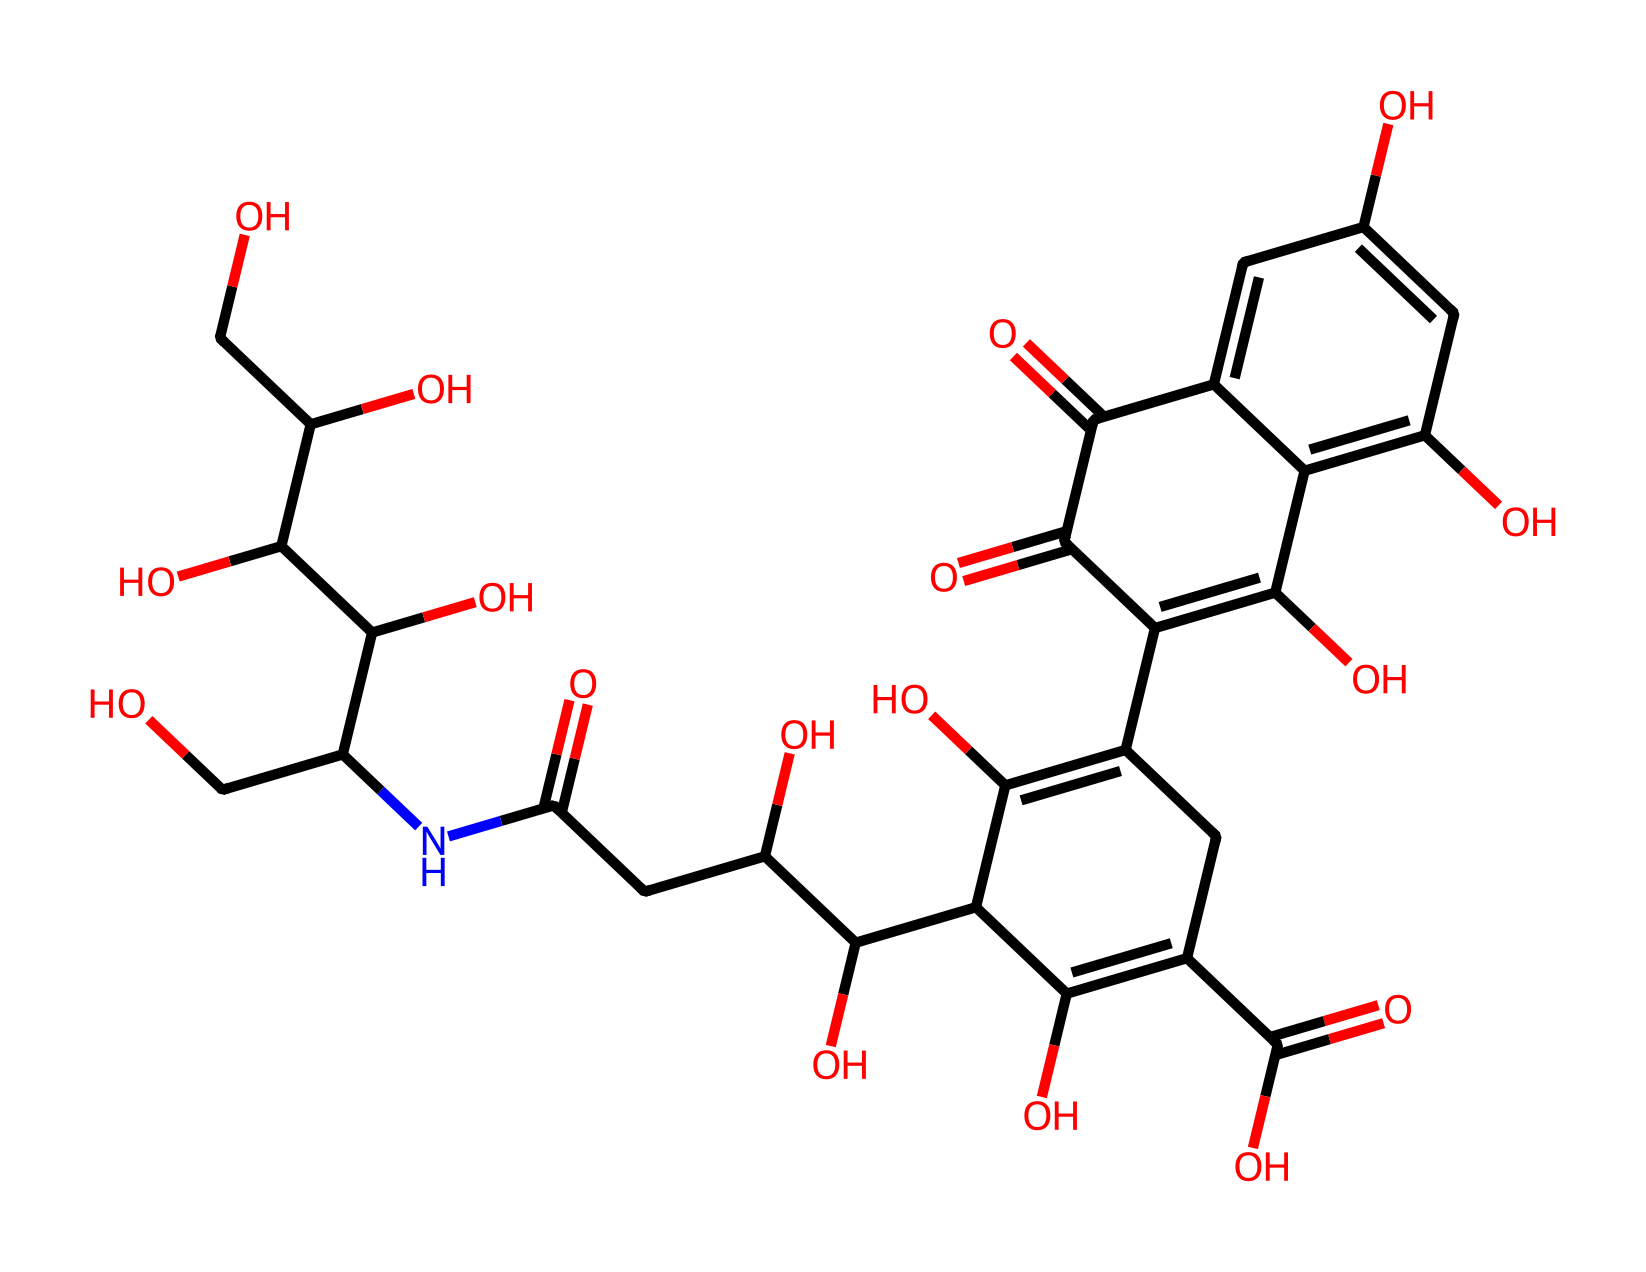What is the molecular formula of betanin? To determine the molecular formula, we count all the different atoms present in the SMILES representation. Looking through the structure, we find carbon (C), hydrogen (H), nitrogen (N), and oxygen (O) atoms. The molecular formula can then be summarized as C20H24N2O9.
Answer: C20H24N2O9 How many rings are present in the structure of betanin? By analyzing the SMILES representation closely, we note the presence of multiple cyclic structures. Specifically, there are two distinct rings in the structure that can be visualized from the connections in the SMILES notation.
Answer: 2 What functional groups can be identified in betanin? The structure reveals multiple functional groups such as hydroxyl groups (-OH) and carboxylic acid groups (-COOH). Each identifiable group contributes to the properties of betanin.
Answer: hydroxyl and carboxylic acid Which part of betanin contributes to its color? The chromophore in betanin, which is primarily responsible for its vivid red color, lies within the conjugated double bonds present in the ring systems. These features allow the molecule to absorb light in specific wavelengths, contributing to its color.
Answer: conjugated double bonds What is the degree of unsaturation in betanin? The degree of unsaturation can be determined by analyzing the presence of multiple bonds and rings in the molecule. In betanin's structure, we can identify several double bonds and rings which leads to a calculated degree of unsaturation calculated to be 9.
Answer: 9 How does the presence of nitrogen affect betanin's properties? The nitrogen atom contributes to the basicity and potential biological activity of betanin. It typically introduces a site for protonation, helping enhance the solubility and reactivity in various environments.
Answer: enhances basicity What role does betanin play as a dye? Betanin serves as a natural dye due to its stability and vivid color. Its ability to bind to various materials allows it to be effectively used in food and cosmetics industries.
Answer: natural dye 